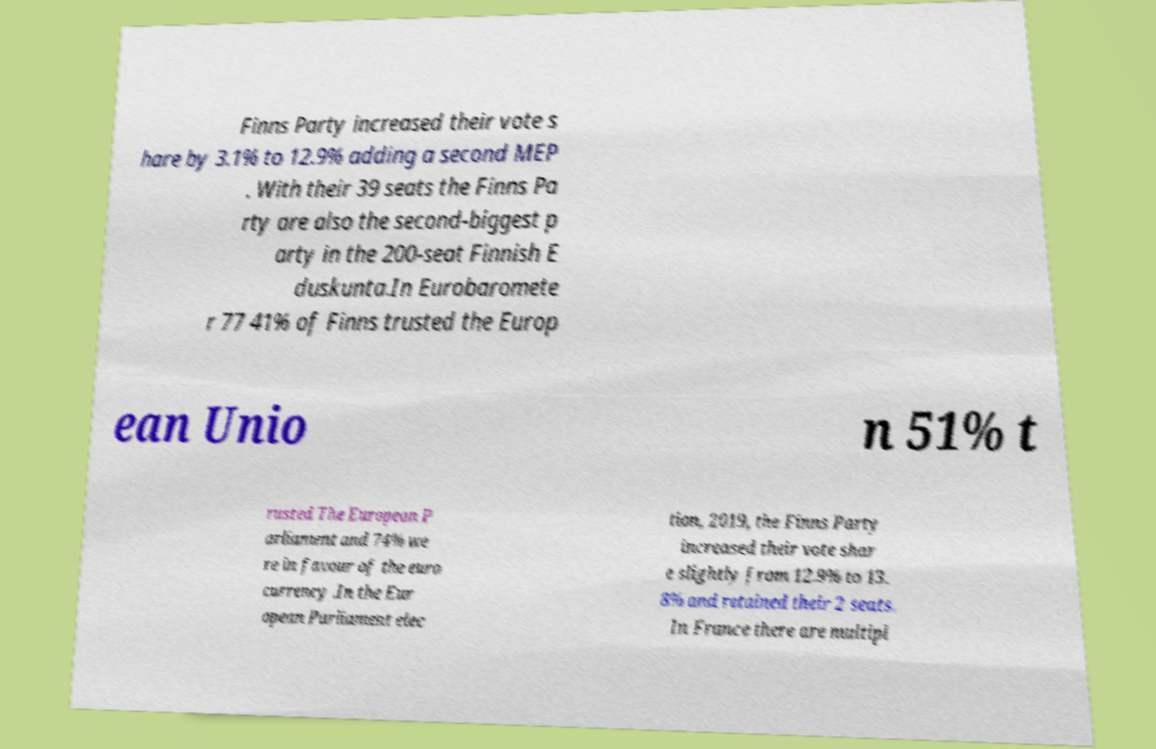Could you extract and type out the text from this image? Finns Party increased their vote s hare by 3.1% to 12.9% adding a second MEP . With their 39 seats the Finns Pa rty are also the second-biggest p arty in the 200-seat Finnish E duskunta.In Eurobaromete r 77 41% of Finns trusted the Europ ean Unio n 51% t rusted The European P arliament and 74% we re in favour of the euro currency .In the Eur opean Parliament elec tion, 2019, the Finns Party increased their vote shar e slightly from 12.9% to 13. 8% and retained their 2 seats. In France there are multipl 